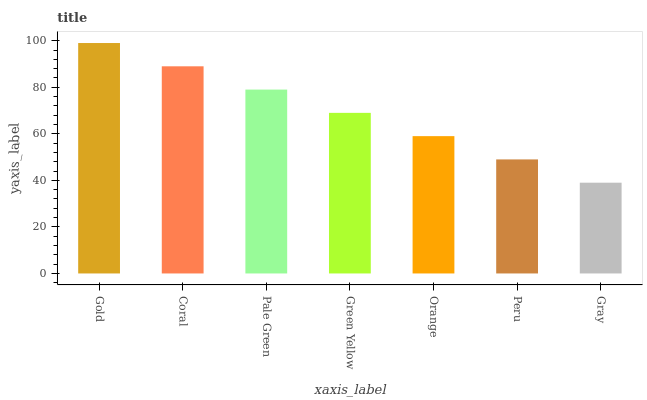Is Coral the minimum?
Answer yes or no. No. Is Coral the maximum?
Answer yes or no. No. Is Gold greater than Coral?
Answer yes or no. Yes. Is Coral less than Gold?
Answer yes or no. Yes. Is Coral greater than Gold?
Answer yes or no. No. Is Gold less than Coral?
Answer yes or no. No. Is Green Yellow the high median?
Answer yes or no. Yes. Is Green Yellow the low median?
Answer yes or no. Yes. Is Coral the high median?
Answer yes or no. No. Is Orange the low median?
Answer yes or no. No. 